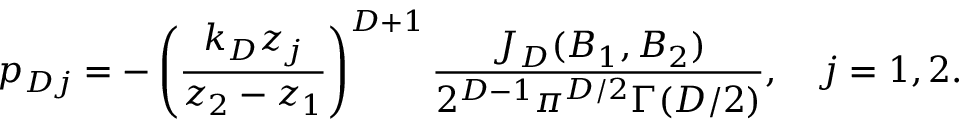Convert formula to latex. <formula><loc_0><loc_0><loc_500><loc_500>p _ { D j } = - \left ( \frac { k _ { D } z _ { j } } { z _ { 2 } - z _ { 1 } } \right ) ^ { D + 1 } \frac { J _ { D } ( B _ { 1 } , B _ { 2 } ) } { 2 ^ { D - 1 } \pi ^ { D / 2 } \Gamma ( D / 2 ) } , \quad j = 1 , 2 .</formula> 